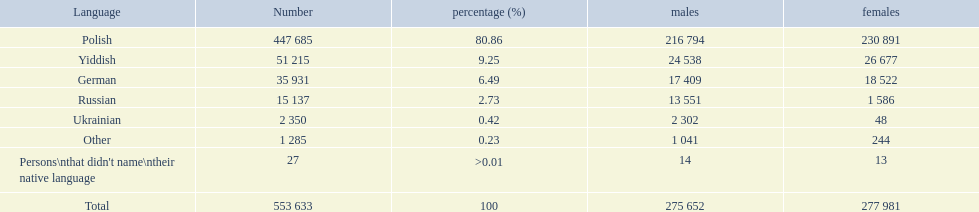What vernaculars can be found? Polish, Yiddish, German, Russian, Ukrainian. What counts converse in these vernaculars? 447 685, 51 215, 35 931, 15 137, 2 350. What counts are not specified as conversing in these vernaculars? 1 285, 27. What are the overall quantities of these speakers? 553 633. 